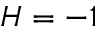Convert formula to latex. <formula><loc_0><loc_0><loc_500><loc_500>H = - 1</formula> 